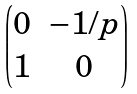Convert formula to latex. <formula><loc_0><loc_0><loc_500><loc_500>\begin{pmatrix} 0 & - 1 / p \\ 1 & 0 \end{pmatrix}</formula> 